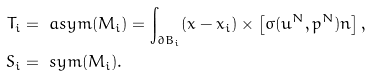Convert formula to latex. <formula><loc_0><loc_0><loc_500><loc_500>T _ { i } & = \ a s y m ( M _ { i } ) = \int _ { \partial B _ { i } } ( x - x _ { i } ) \times \left [ \sigma ( u ^ { N } , p ^ { N } ) n \right ] , \\ S _ { i } & = \ s y m ( M _ { i } ) .</formula> 